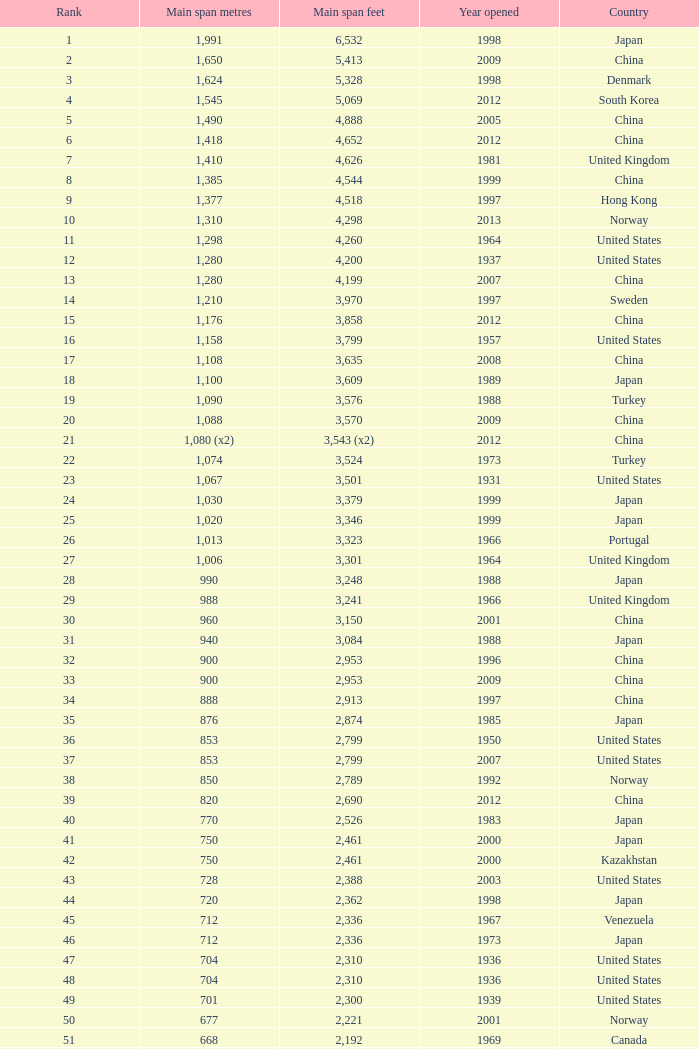What is the maximum rank achieved for a 430-meter main span in years later than 2010? 94.0. Would you be able to parse every entry in this table? {'header': ['Rank', 'Main span metres', 'Main span feet', 'Year opened', 'Country'], 'rows': [['1', '1,991', '6,532', '1998', 'Japan'], ['2', '1,650', '5,413', '2009', 'China'], ['3', '1,624', '5,328', '1998', 'Denmark'], ['4', '1,545', '5,069', '2012', 'South Korea'], ['5', '1,490', '4,888', '2005', 'China'], ['6', '1,418', '4,652', '2012', 'China'], ['7', '1,410', '4,626', '1981', 'United Kingdom'], ['8', '1,385', '4,544', '1999', 'China'], ['9', '1,377', '4,518', '1997', 'Hong Kong'], ['10', '1,310', '4,298', '2013', 'Norway'], ['11', '1,298', '4,260', '1964', 'United States'], ['12', '1,280', '4,200', '1937', 'United States'], ['13', '1,280', '4,199', '2007', 'China'], ['14', '1,210', '3,970', '1997', 'Sweden'], ['15', '1,176', '3,858', '2012', 'China'], ['16', '1,158', '3,799', '1957', 'United States'], ['17', '1,108', '3,635', '2008', 'China'], ['18', '1,100', '3,609', '1989', 'Japan'], ['19', '1,090', '3,576', '1988', 'Turkey'], ['20', '1,088', '3,570', '2009', 'China'], ['21', '1,080 (x2)', '3,543 (x2)', '2012', 'China'], ['22', '1,074', '3,524', '1973', 'Turkey'], ['23', '1,067', '3,501', '1931', 'United States'], ['24', '1,030', '3,379', '1999', 'Japan'], ['25', '1,020', '3,346', '1999', 'Japan'], ['26', '1,013', '3,323', '1966', 'Portugal'], ['27', '1,006', '3,301', '1964', 'United Kingdom'], ['28', '990', '3,248', '1988', 'Japan'], ['29', '988', '3,241', '1966', 'United Kingdom'], ['30', '960', '3,150', '2001', 'China'], ['31', '940', '3,084', '1988', 'Japan'], ['32', '900', '2,953', '1996', 'China'], ['33', '900', '2,953', '2009', 'China'], ['34', '888', '2,913', '1997', 'China'], ['35', '876', '2,874', '1985', 'Japan'], ['36', '853', '2,799', '1950', 'United States'], ['37', '853', '2,799', '2007', 'United States'], ['38', '850', '2,789', '1992', 'Norway'], ['39', '820', '2,690', '2012', 'China'], ['40', '770', '2,526', '1983', 'Japan'], ['41', '750', '2,461', '2000', 'Japan'], ['42', '750', '2,461', '2000', 'Kazakhstan'], ['43', '728', '2,388', '2003', 'United States'], ['44', '720', '2,362', '1998', 'Japan'], ['45', '712', '2,336', '1967', 'Venezuela'], ['46', '712', '2,336', '1973', 'Japan'], ['47', '704', '2,310', '1936', 'United States'], ['48', '704', '2,310', '1936', 'United States'], ['49', '701', '2,300', '1939', 'United States'], ['50', '677', '2,221', '2001', 'Norway'], ['51', '668', '2,192', '1969', 'Canada'], ['52', '656', '2,152', '1968', 'United States'], ['53', '656', '2152', '1951', 'United States'], ['54', '648', '2,126', '1999', 'China'], ['55', '636', '2,087', '2009', 'China'], ['56', '623', '2,044', '1992', 'Norway'], ['57', '616', '2,021', '2009', 'China'], ['58', '610', '2,001', '1957', 'United States'], ['59', '608', '1,995', '1959', 'France'], ['60', '600', '1,969', '1970', 'Denmark'], ['61', '600', '1,969', '1999', 'Japan'], ['62', '600', '1,969', '2000', 'China'], ['63', '595', '1,952', '1997', 'Norway'], ['64', '580', '1,903', '2003', 'China'], ['65', '577', '1,893', '2001', 'Norway'], ['66', '570', '1,870', '1993', 'Japan'], ['67', '564', '1,850', '1929', 'United States Canada'], ['68', '560', '1,837', '1988', 'Japan'], ['69', '560', '1,837', '2001', 'China'], ['70', '549', '1,801', '1961', 'United States'], ['71', '540', '1,772', '2008', 'Japan'], ['72', '534', '1,752', '1926', 'United States'], ['73', '525', '1,722', '1972', 'Norway'], ['74', '525', '1,722', '1977', 'Norway'], ['75', '520', '1,706', '1983', 'Democratic Republic of the Congo'], ['76', '500', '1,640', '1965', 'Germany'], ['77', '500', '1,640', '2002', 'South Korea'], ['78', '497', '1,631', '1924', 'United States'], ['79', '488', '1,601', '1903', 'United States'], ['80', '488', '1,601', '1969', 'United States'], ['81', '488', '1,601', '1952', 'United States'], ['82', '488', '1,601', '1973', 'United States'], ['83', '486', '1,594', '1883', 'United States'], ['84', '473', '1,552', '1938', 'Canada'], ['85', '468', '1,535', '1971', 'Norway'], ['86', '465', '1,526', '1977', 'Japan'], ['87', '457', '1,499', '1930', 'United States'], ['88', '457', '1,499', '1963', 'United States'], ['89', '452', '1,483', '1995', 'China'], ['90', '450', '1,476', '1997', 'China'], ['91', '448', '1,470', '1909', 'United States'], ['92', '446', '1,463', '1997', 'Norway'], ['93', '441', '1,447', '1955', 'Canada'], ['94', '430', '1,411', '2012', 'China'], ['95', '427', '1,401', '1970', 'Canada'], ['96', '421', '1,381', '1936', 'United States'], ['97', '417', '1,368', '1966', 'Sweden'], ['98', '408', '1339', '2010', 'China'], ['99', '405', '1,329', '2009', 'Vietnam'], ['100', '404', '1,325', '1973', 'South Korea'], ['101', '394', '1,293', '1967', 'France'], ['102', '390', '1,280', '1964', 'Uzbekistan'], ['103', '385', '1,263', '2013', 'United States'], ['104', '378', '1,240', '1954', 'Germany'], ['105', '368', '1,207', '1931', 'United States'], ['106', '367', '1,204', '1962', 'Japan'], ['107', '366', '1,200', '1929', 'United States'], ['108', '351', '1,151', '1960', 'United States Canada'], ['109', '350', '1,148', '2006', 'China'], ['110', '340', '1,115', '1926', 'Brazil'], ['111', '338', '1,109', '2001', 'China'], ['112', '338', '1,108', '1965', 'United States'], ['113', '337', '1,106', '1956', 'Norway'], ['114', '335', '1,100', '1961', 'United Kingdom'], ['115', '335', '1,100', '2006', 'Norway'], ['116', '329', '1,088', '1939', 'United States'], ['117', '328', '1,085', '1939', 'Zambia Zimbabwe'], ['118', '325', '1,066', '1964', 'Norway'], ['119', '325', '1,066', '1981', 'Norway'], ['120', '323', '1,060', '1932', 'United States'], ['121', '323', '1,059', '1936', 'Canada'], ['122', '322', '1,057', '1867', 'United States'], ['123', '320', '1,050', '1971', 'United States'], ['124', '320', '1,050', '2011', 'Peru'], ['125', '315', '1,033', '1951', 'Germany'], ['126', '308', '1,010', '1849', 'United States'], ['127', '300', '985', '1961', 'Canada'], ['128', '300', '984', '1987', 'Japan'], ['129', '300', '984', '2000', 'France'], ['130', '300', '984', '2000', 'South Korea']]} 